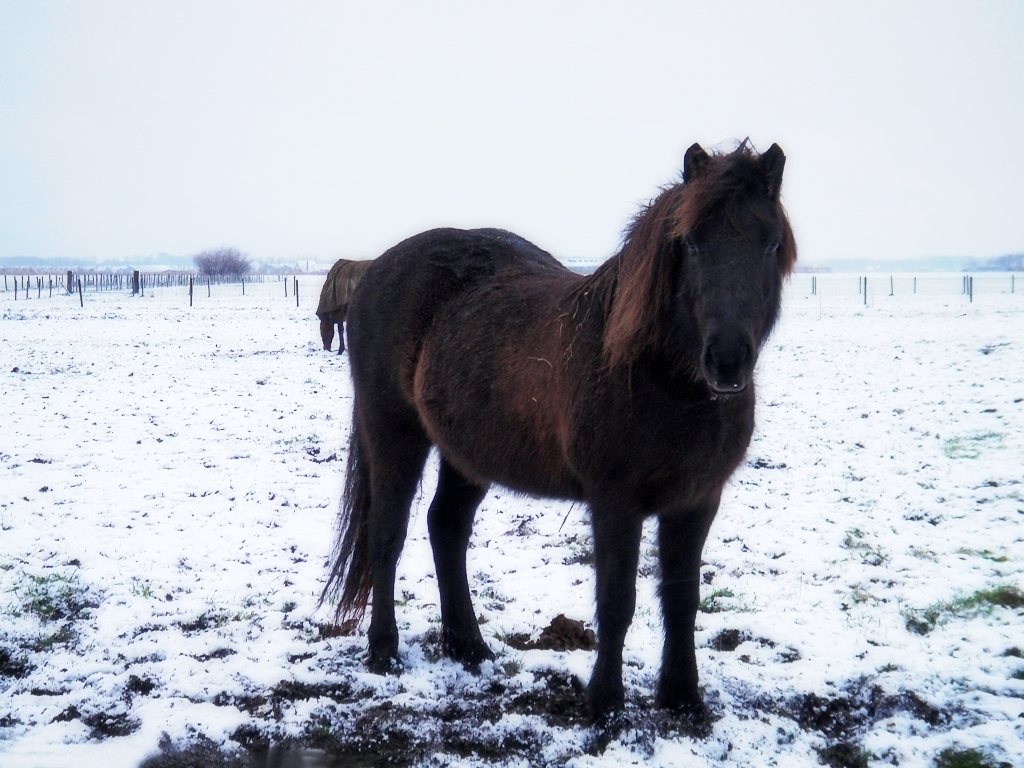What might be the horse's emotional state or behavior in a setting like this? The horse appears calm and stoic, standing solitary against the wintery backdrop. Its posture and relaxed ears suggest it is at ease in its environment, accustomed to the solitude and quietude. The lack of active engagement with its surroundings typically indicates contentment or a resting state. Could the horse's solitary presence imply something about its lifestyle? The solitary nature of the horse in this scene could suggest that it is used to a more free-range lifestyle, with ample space to roam. It may be accustomed to periods of solitude, or it may simply be captured in a moment apart from any herd or companion animals it might typically associate with. 